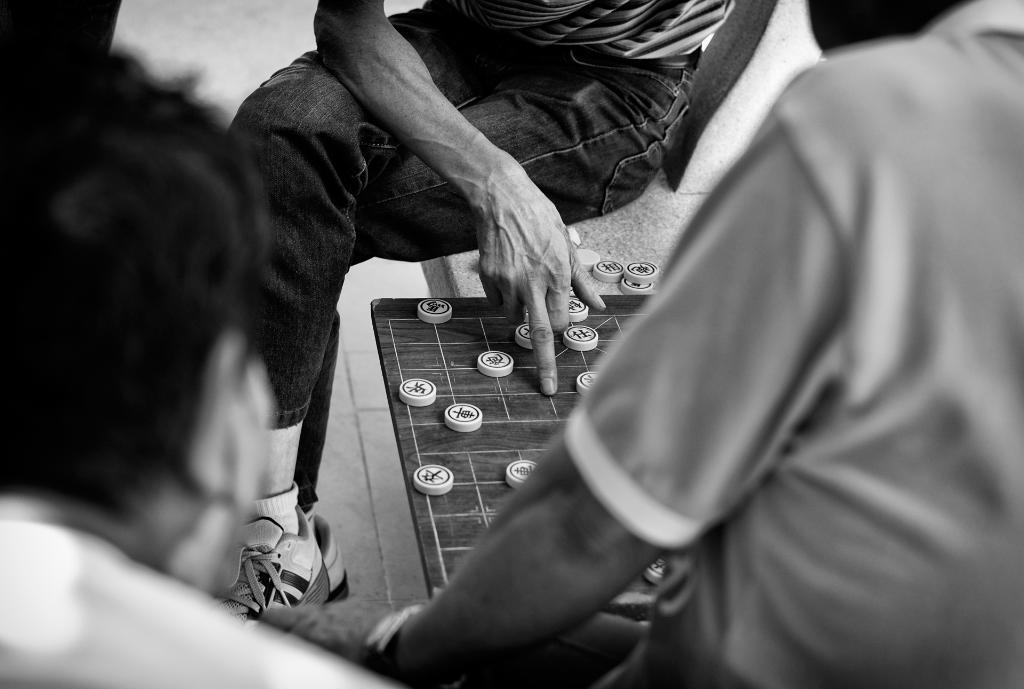Can you describe this image briefly? This is black and white picture, in this picture there are people and we can see board and coins on the platform. 